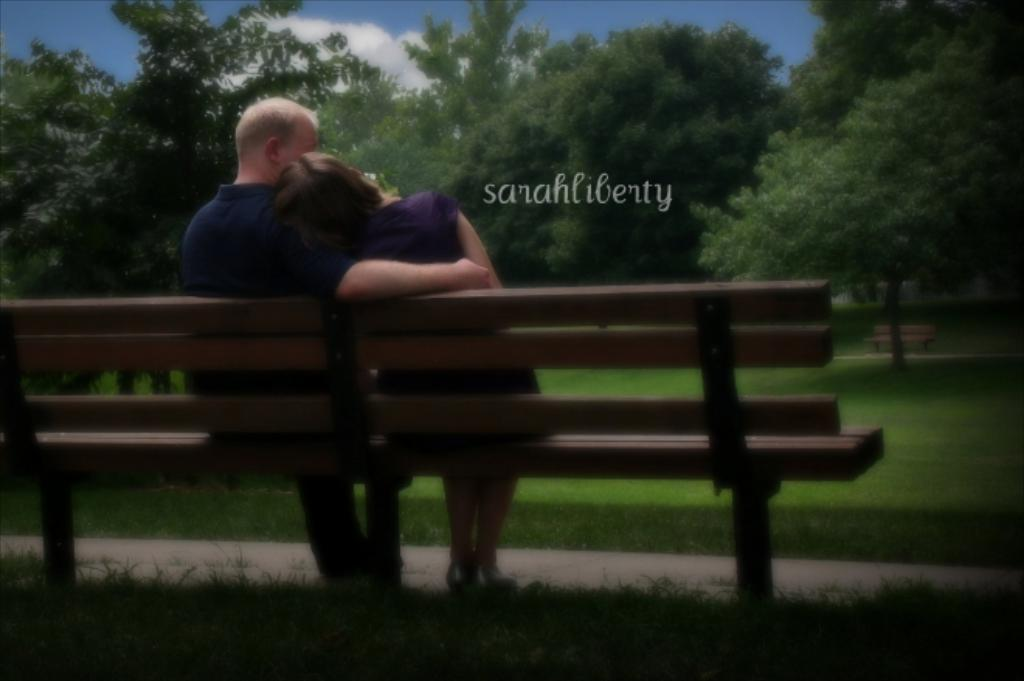How many people are sitting on the bench in the image? There are two persons sitting on a bench in the image. What color is the grass in the image? The grass is green in color. What can be seen in the distance beyond the grass? There are multiple trees visible in the distance. Can you see a baby playing with a boat near the bench in the image? There is no baby or boat present in the image. Is there a bear visible in the image? There is no bear present in the image. 